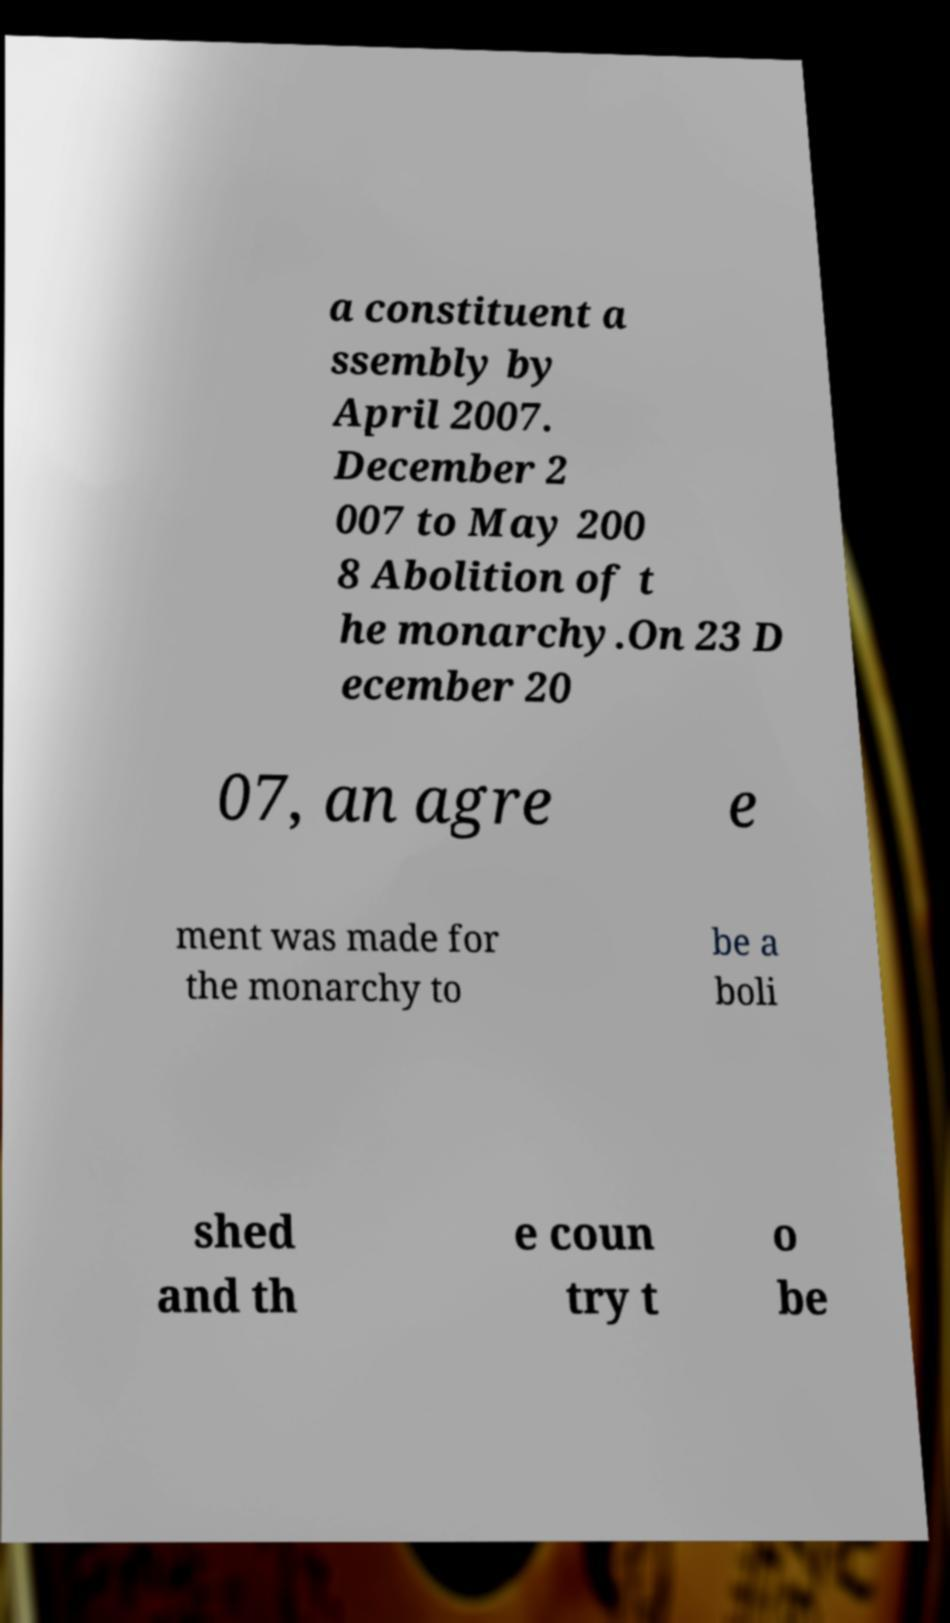Please read and relay the text visible in this image. What does it say? a constituent a ssembly by April 2007. December 2 007 to May 200 8 Abolition of t he monarchy.On 23 D ecember 20 07, an agre e ment was made for the monarchy to be a boli shed and th e coun try t o be 